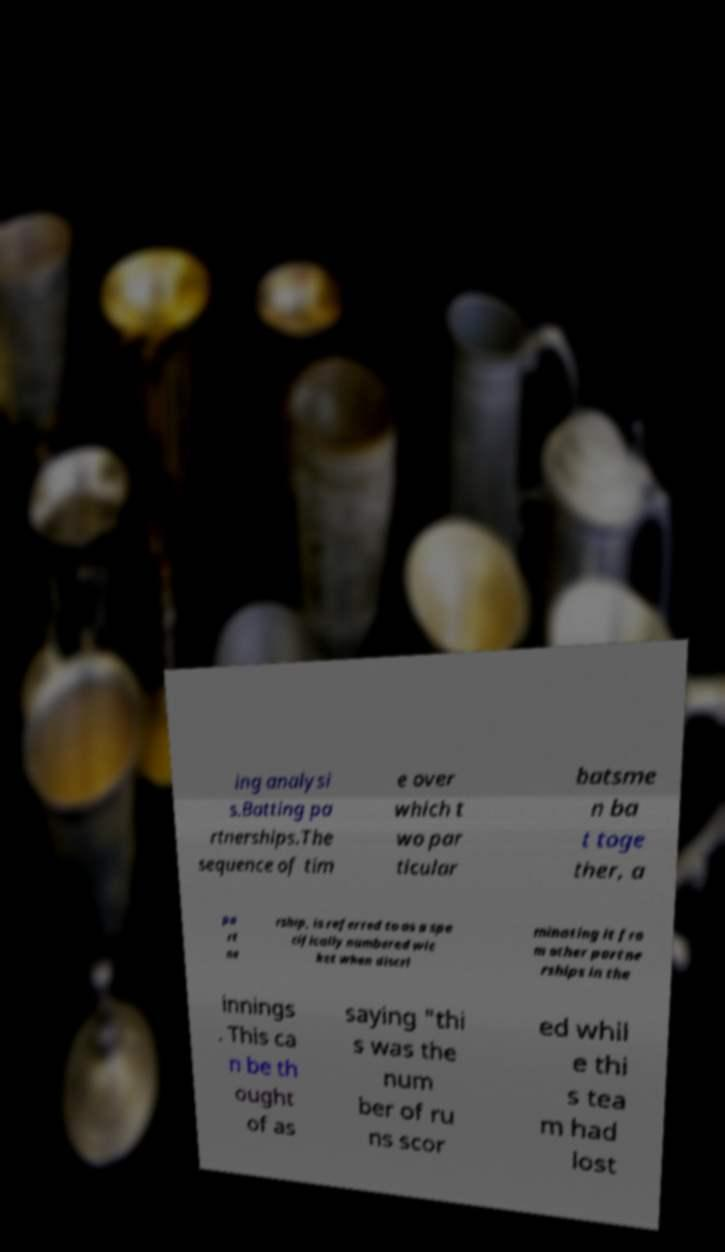Can you accurately transcribe the text from the provided image for me? ing analysi s.Batting pa rtnerships.The sequence of tim e over which t wo par ticular batsme n ba t toge ther, a pa rt ne rship, is referred to as a spe cifically numbered wic ket when discri minating it fro m other partne rships in the innings . This ca n be th ought of as saying "thi s was the num ber of ru ns scor ed whil e thi s tea m had lost 